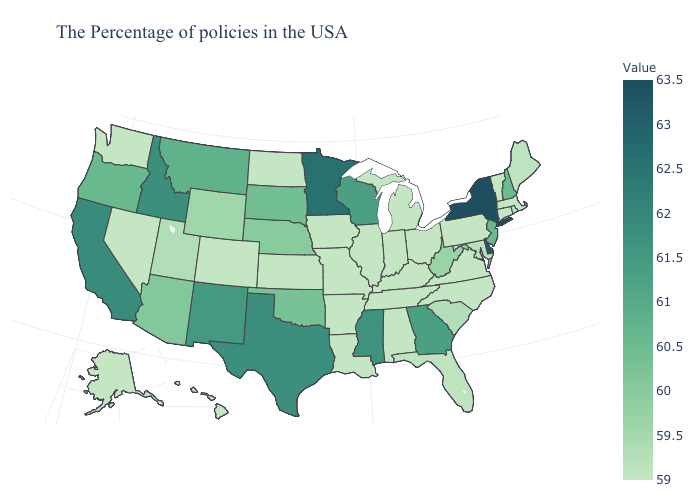Does the map have missing data?
Give a very brief answer. No. Does Georgia have a higher value than Minnesota?
Answer briefly. No. Among the states that border New Mexico , does Colorado have the lowest value?
Give a very brief answer. Yes. Among the states that border Alabama , which have the lowest value?
Keep it brief. Tennessee. Which states have the lowest value in the USA?
Keep it brief. Massachusetts, Vermont, Connecticut, Pennsylvania, Virginia, North Carolina, Ohio, Michigan, Kentucky, Indiana, Alabama, Tennessee, Illinois, Louisiana, Missouri, Arkansas, Iowa, Kansas, North Dakota, Colorado, Nevada, Washington, Alaska, Hawaii. 